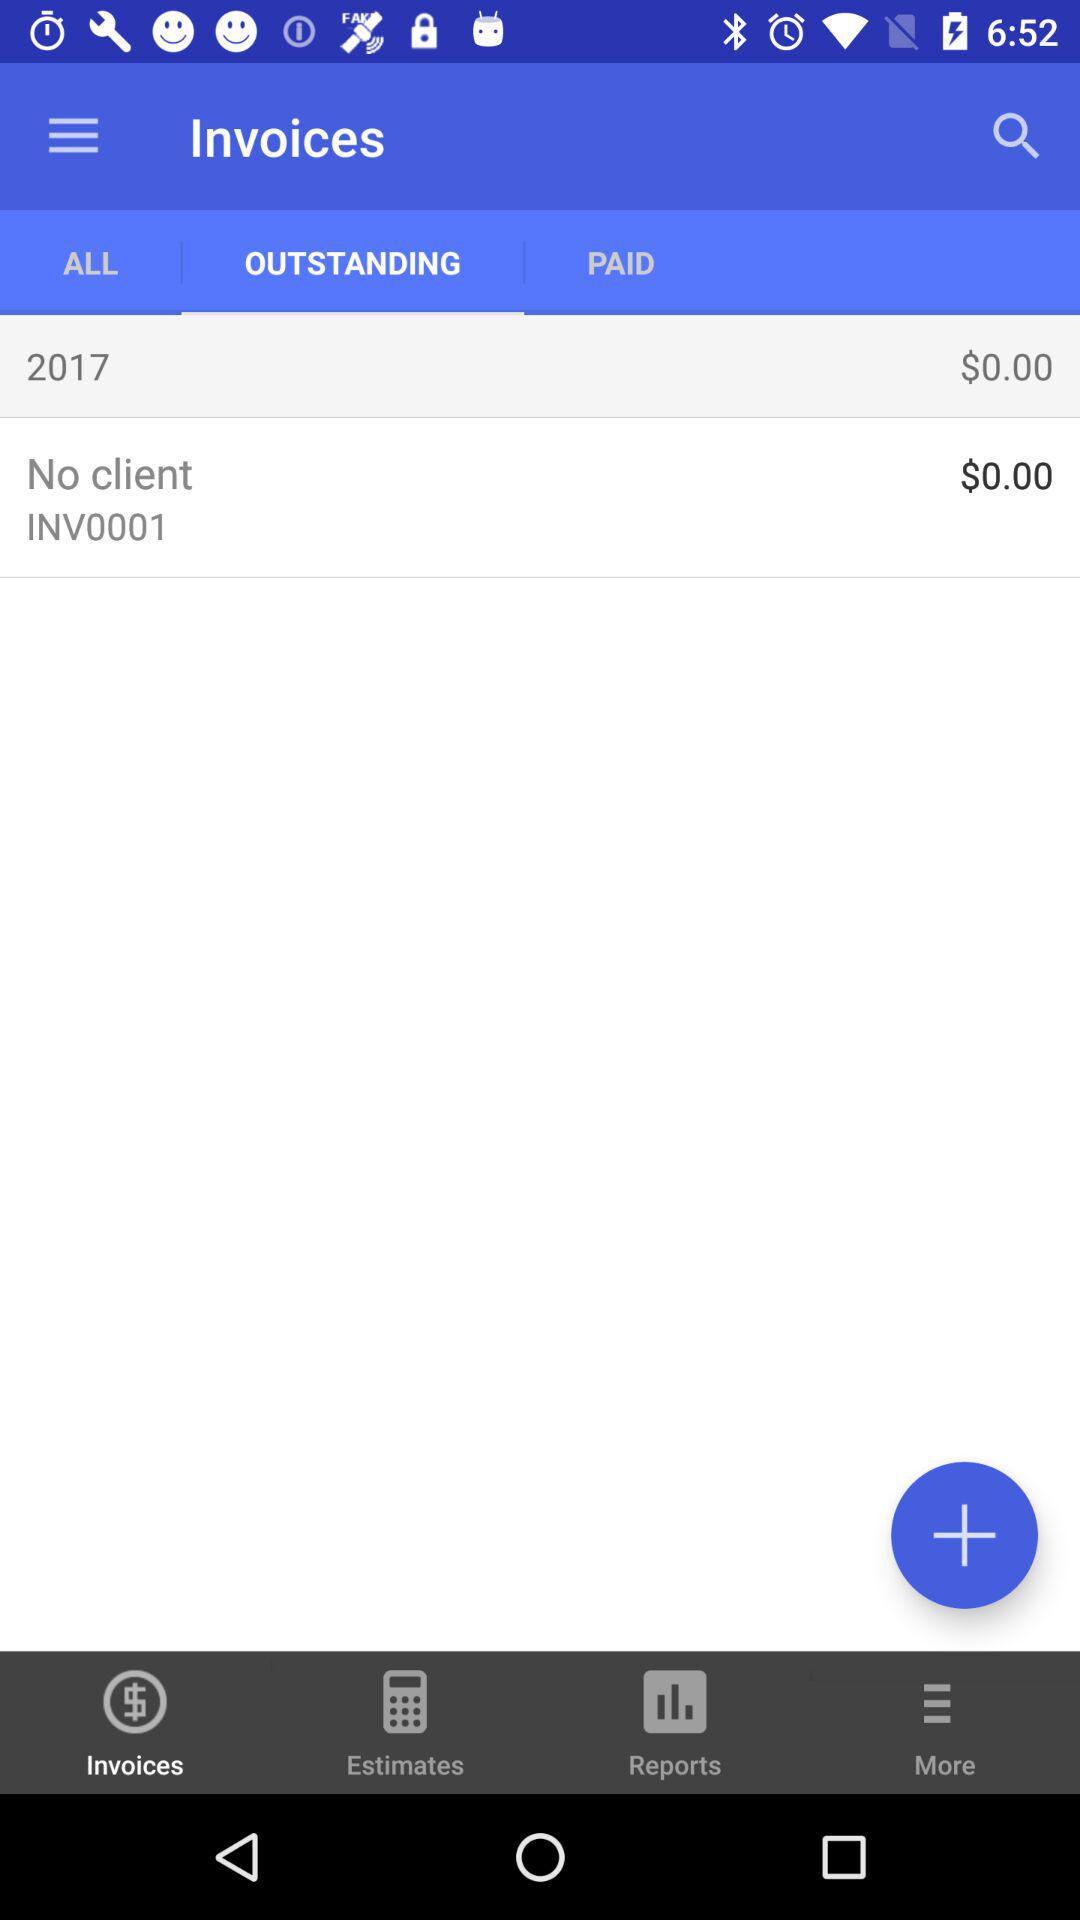What is the amount of the "No client"? The amount is $0. 